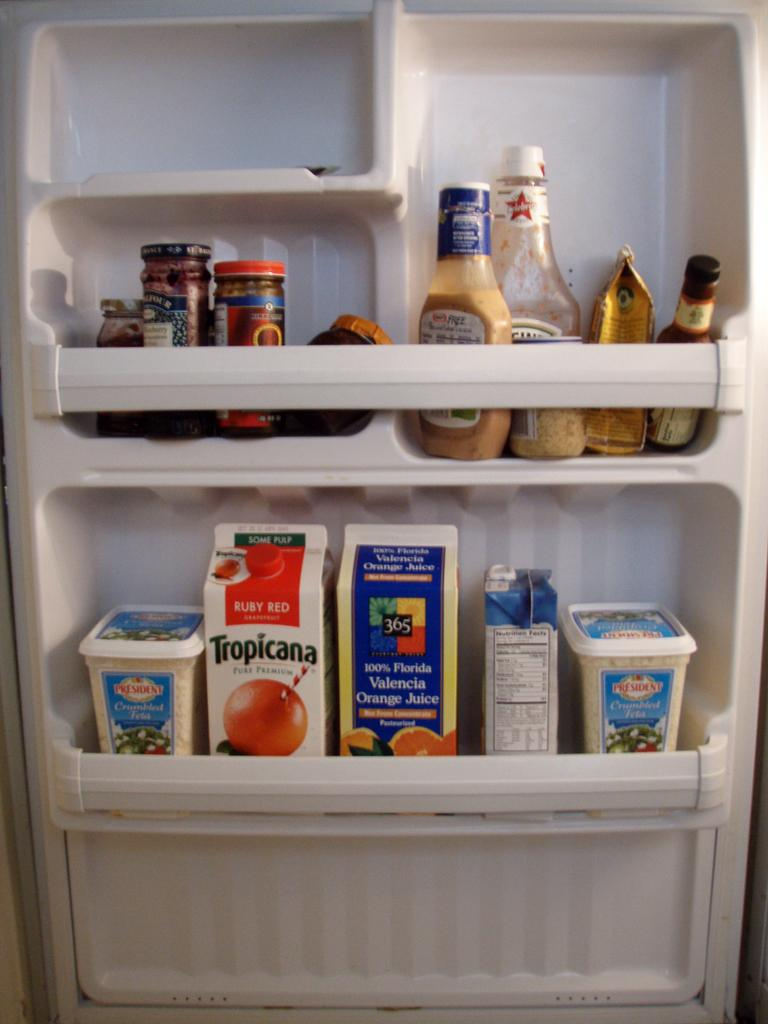What types of items are in the foreground of the image? There are bottles, tetra packs, and containers in the foreground of the image. Where are these items located? These items are located on a fridge door. What can be inferred about the purpose of these items? The presence of bottles, tetra packs, and containers suggests that they are likely used for storing or containing food or beverages. What type of painting is hanging on the fridge door in the image? There is no painting or canvas present in the image; it only features bottles, tetra packs, and containers on a fridge door. 